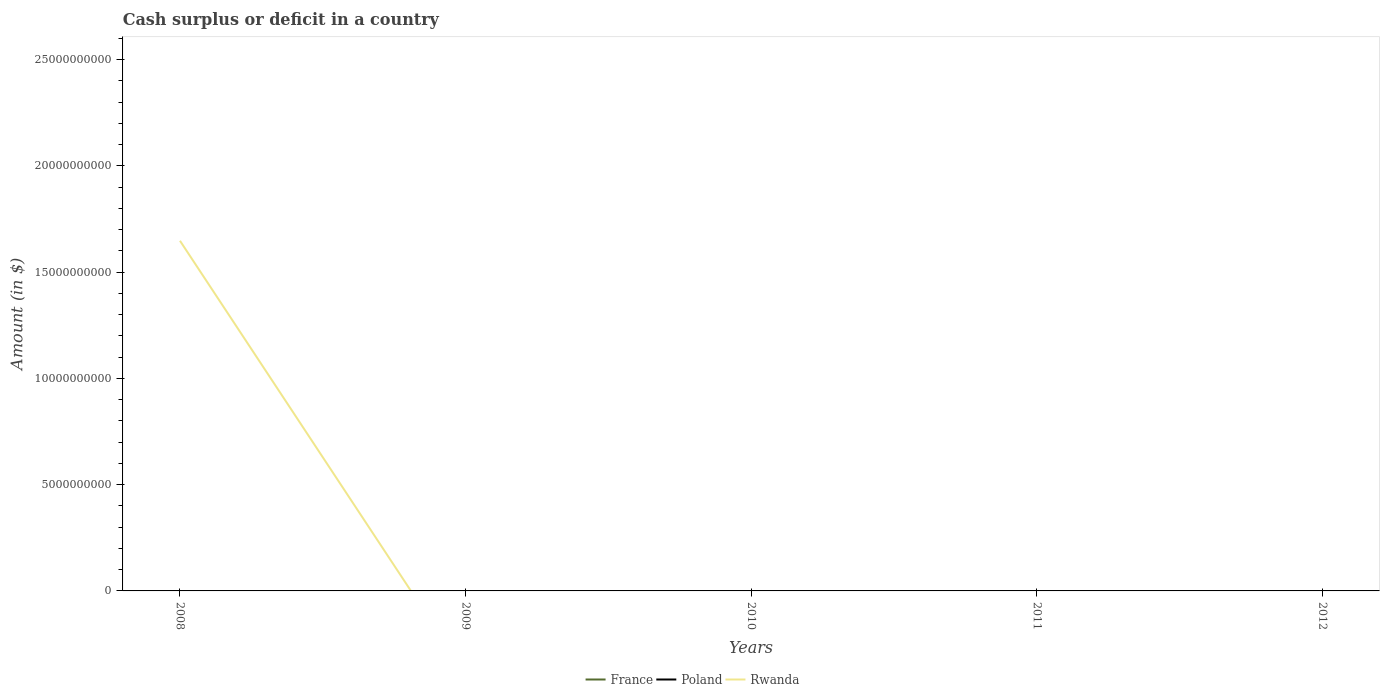What is the difference between the highest and the second highest amount of cash surplus or deficit in Rwanda?
Your answer should be compact. 1.65e+1. How many lines are there?
Ensure brevity in your answer.  1. How many years are there in the graph?
Your answer should be very brief. 5. What is the difference between two consecutive major ticks on the Y-axis?
Provide a short and direct response. 5.00e+09. Are the values on the major ticks of Y-axis written in scientific E-notation?
Provide a short and direct response. No. Does the graph contain any zero values?
Your answer should be compact. Yes. Does the graph contain grids?
Your answer should be very brief. No. What is the title of the graph?
Provide a succinct answer. Cash surplus or deficit in a country. Does "South Asia" appear as one of the legend labels in the graph?
Your response must be concise. No. What is the label or title of the X-axis?
Give a very brief answer. Years. What is the label or title of the Y-axis?
Make the answer very short. Amount (in $). What is the Amount (in $) of Rwanda in 2008?
Provide a short and direct response. 1.65e+1. What is the Amount (in $) of France in 2009?
Offer a terse response. 0. What is the Amount (in $) in Rwanda in 2009?
Offer a terse response. 0. What is the Amount (in $) of France in 2010?
Keep it short and to the point. 0. What is the Amount (in $) in Poland in 2010?
Ensure brevity in your answer.  0. What is the Amount (in $) in Rwanda in 2010?
Your answer should be very brief. 0. What is the Amount (in $) of France in 2011?
Give a very brief answer. 0. What is the Amount (in $) of Poland in 2011?
Your response must be concise. 0. What is the Amount (in $) in France in 2012?
Make the answer very short. 0. What is the Amount (in $) in Poland in 2012?
Provide a short and direct response. 0. Across all years, what is the maximum Amount (in $) of Rwanda?
Offer a very short reply. 1.65e+1. Across all years, what is the minimum Amount (in $) of Rwanda?
Make the answer very short. 0. What is the total Amount (in $) of Rwanda in the graph?
Ensure brevity in your answer.  1.65e+1. What is the average Amount (in $) in France per year?
Give a very brief answer. 0. What is the average Amount (in $) of Rwanda per year?
Provide a short and direct response. 3.30e+09. What is the difference between the highest and the lowest Amount (in $) in Rwanda?
Offer a terse response. 1.65e+1. 